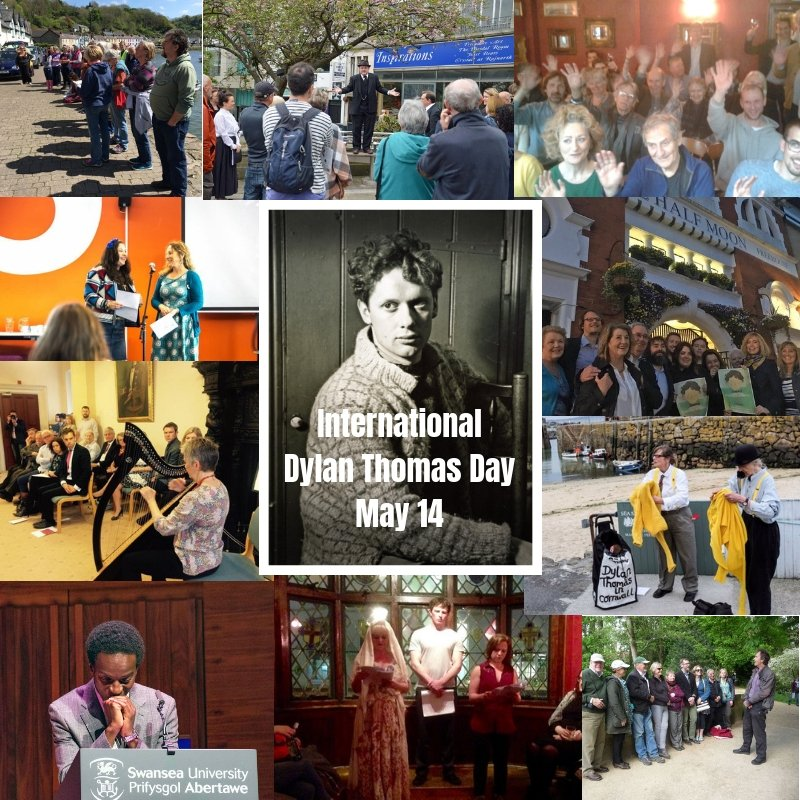What realistic scenarios could the people in the center left image be experiencing during International Dylan Thomas Day? In the center left image, the people might be attending a poetry reading session at a local café, where participants take turns reading aloud their favorite Dylan Thomas poems. The intimate setting allows for a deep appreciation of Thomas's rhythmic and emotive language, fostering a sense of community among the attendees. Alternatively, they could be enjoying a roundtable discussion at a bookshop, where literary enthusiasts discuss Thomas's impact on modern poetry, share personal stories about encountering his work, and critically analyze his most famous pieces. The atmosphere would be one of camaraderie and shared passion for literature.  Describe a short scenario involving the people standing on the beach in the bottom right photo. On the beach in the bottom right photo, the group of people might be enjoying a serene seaside poetry reading. With the waves gently crashing in the background, a speaker reads Thomas's evocative lines, allowing the natural rhythm of the ocean to underscore the cadence of the poetry. The attendees, wrapped in warm clothing against the coastal breeze, listen intently, finding a deeper connection to Thomas's themes of nature and the passage of time. 